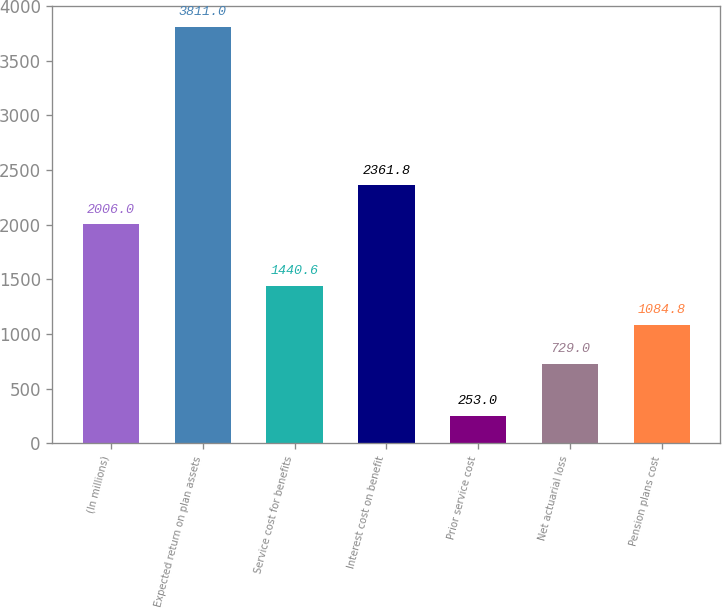Convert chart. <chart><loc_0><loc_0><loc_500><loc_500><bar_chart><fcel>(In millions)<fcel>Expected return on plan assets<fcel>Service cost for benefits<fcel>Interest cost on benefit<fcel>Prior service cost<fcel>Net actuarial loss<fcel>Pension plans cost<nl><fcel>2006<fcel>3811<fcel>1440.6<fcel>2361.8<fcel>253<fcel>729<fcel>1084.8<nl></chart> 